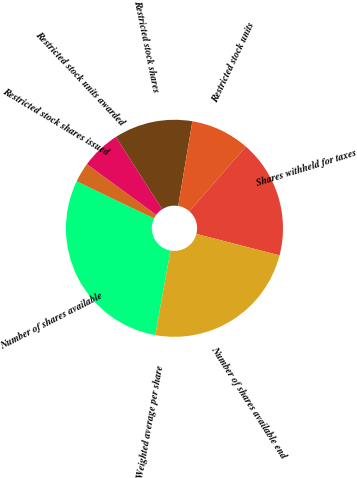Convert chart. <chart><loc_0><loc_0><loc_500><loc_500><pie_chart><fcel>Number of shares available<fcel>Restricted stock shares issued<fcel>Restricted stock units awarded<fcel>Restricted stock shares<fcel>Restricted stock units<fcel>Shares withheld for taxes<fcel>Number of shares available end<fcel>Weighted average per share<nl><fcel>29.3%<fcel>2.93%<fcel>5.86%<fcel>11.72%<fcel>8.79%<fcel>17.58%<fcel>23.81%<fcel>0.0%<nl></chart> 